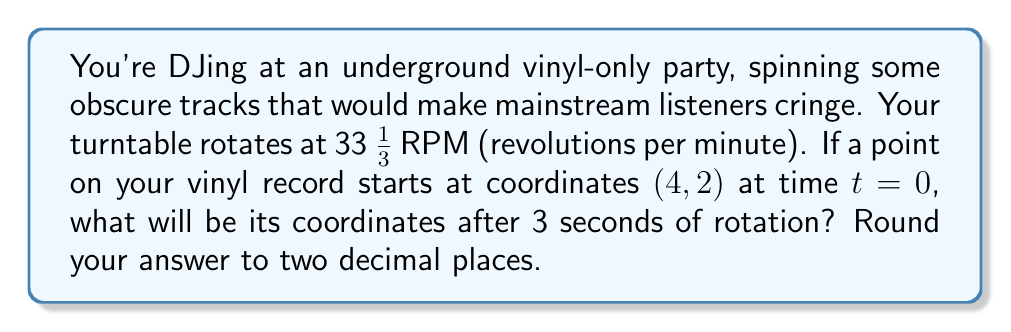Can you solve this math problem? Let's approach this step-by-step:

1) First, we need to calculate the angle of rotation after 3 seconds.
   - The turntable rotates at 33 1/3 RPM = $\frac{100}{3}$ RPM
   - In 1 minute, it rotates $2\pi$ radians
   - So, in 1 second, it rotates $\frac{2\pi}{60} \cdot \frac{100}{3} = \frac{10\pi}{9}$ radians
   - In 3 seconds, it rotates $3 \cdot \frac{10\pi}{9} = \frac{10\pi}{3}$ radians

2) Now, we can use the rotation matrix to transform the coordinates:

   $$\begin{pmatrix} \cos\theta & -\sin\theta \\ \sin\theta & \cos\theta \end{pmatrix} \begin{pmatrix} x \\ y \end{pmatrix} = \begin{pmatrix} x\cos\theta - y\sin\theta \\ x\sin\theta + y\cos\theta \end{pmatrix}$$

   Where $\theta = \frac{10\pi}{3}$

3) Let's calculate:
   
   $$\begin{pmatrix} \cos(\frac{10\pi}{3}) & -\sin(\frac{10\pi}{3}) \\ \sin(\frac{10\pi}{3}) & \cos(\frac{10\pi}{3}) \end{pmatrix} \begin{pmatrix} 4 \\ 2 \end{pmatrix}$$

4) Simplify:
   $\cos(\frac{10\pi}{3}) = \cos(\frac{\pi}{3}) = \frac{1}{2}$
   $\sin(\frac{10\pi}{3}) = -\sin(\frac{\pi}{3}) = -\frac{\sqrt{3}}{2}$

5) Calculate:
   
   $$\begin{pmatrix} \frac{1}{2} & \frac{\sqrt{3}}{2} \\ -\frac{\sqrt{3}}{2} & \frac{1}{2} \end{pmatrix} \begin{pmatrix} 4 \\ 2 \end{pmatrix} = \begin{pmatrix} 4 \cdot \frac{1}{2} + 2 \cdot \frac{\sqrt{3}}{2} \\ 4 \cdot (-\frac{\sqrt{3}}{2}) + 2 \cdot \frac{1}{2} \end{pmatrix}$$

6) Simplify:
   
   $$\begin{pmatrix} 2 + \sqrt{3} \\ -2\sqrt{3} + 1 \end{pmatrix}$$

7) Round to two decimal places:
   
   $$\begin{pmatrix} 3.73 \\ -2.46 \end{pmatrix}$$
Answer: $(3.73, -2.46)$ 